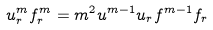<formula> <loc_0><loc_0><loc_500><loc_500>u ^ { m } _ { r } f ^ { m } _ { r } = m ^ { 2 } u ^ { m - 1 } u _ { r } f ^ { m - 1 } f _ { r } \quad</formula> 